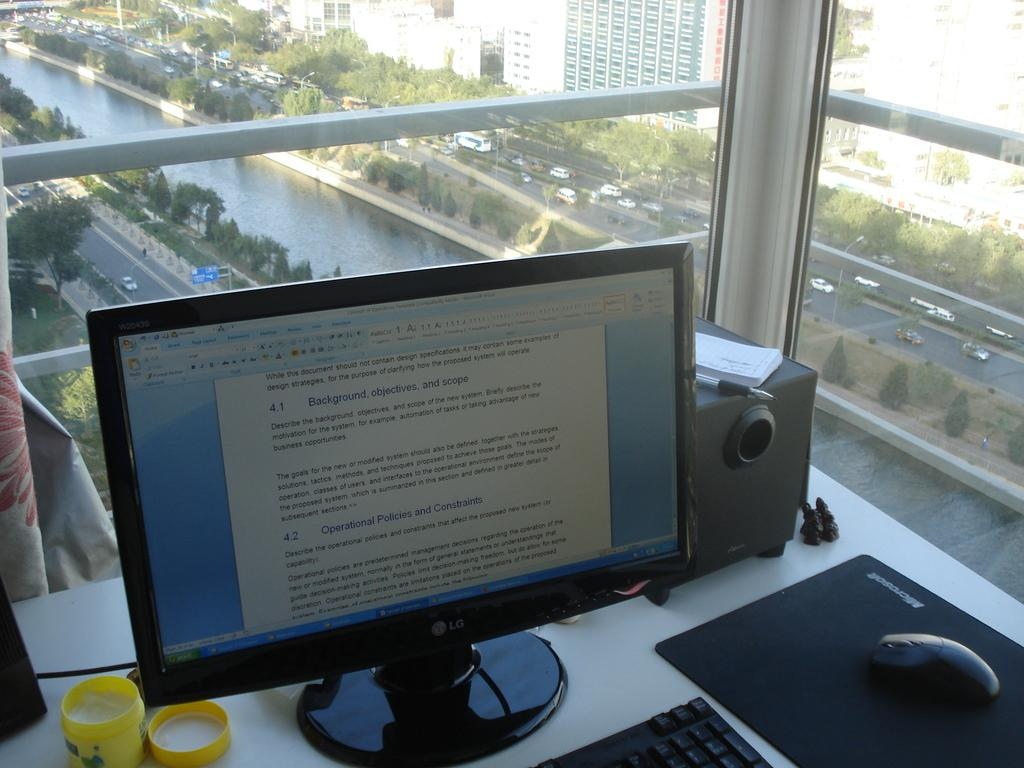<image>
Create a compact narrative representing the image presented. A desk with a LG computer monitor a keyboard and a mouse also a pen and a checkbook 